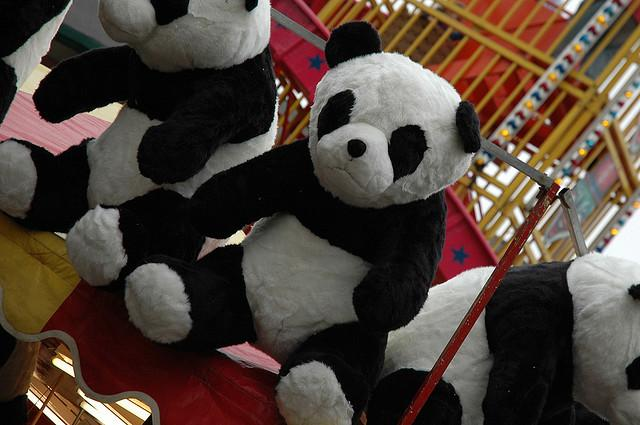This animal is a symbol of what nation? Please explain your reasoning. china. A panda is shown. china is associated with pandas. 